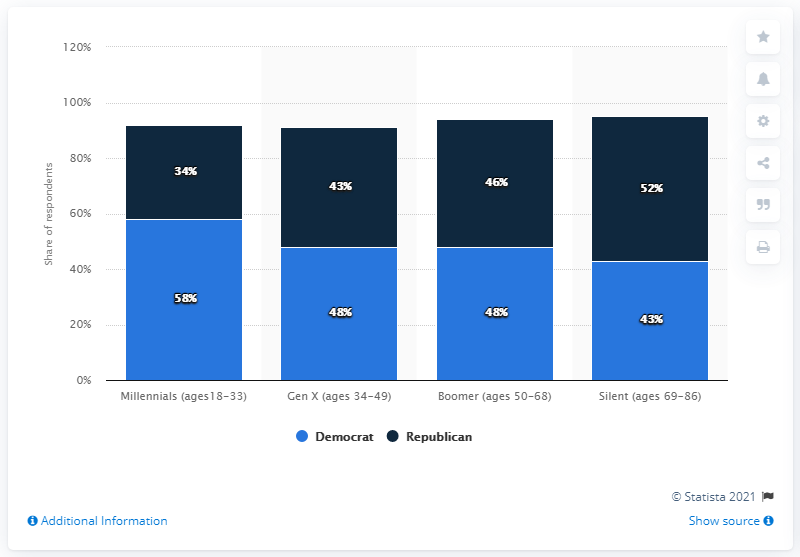Specify some key components in this picture. The highest percentage of Democrats is 58%. The total percentage of baby boomers, defined as those aged 50 to 68, is 94%. 